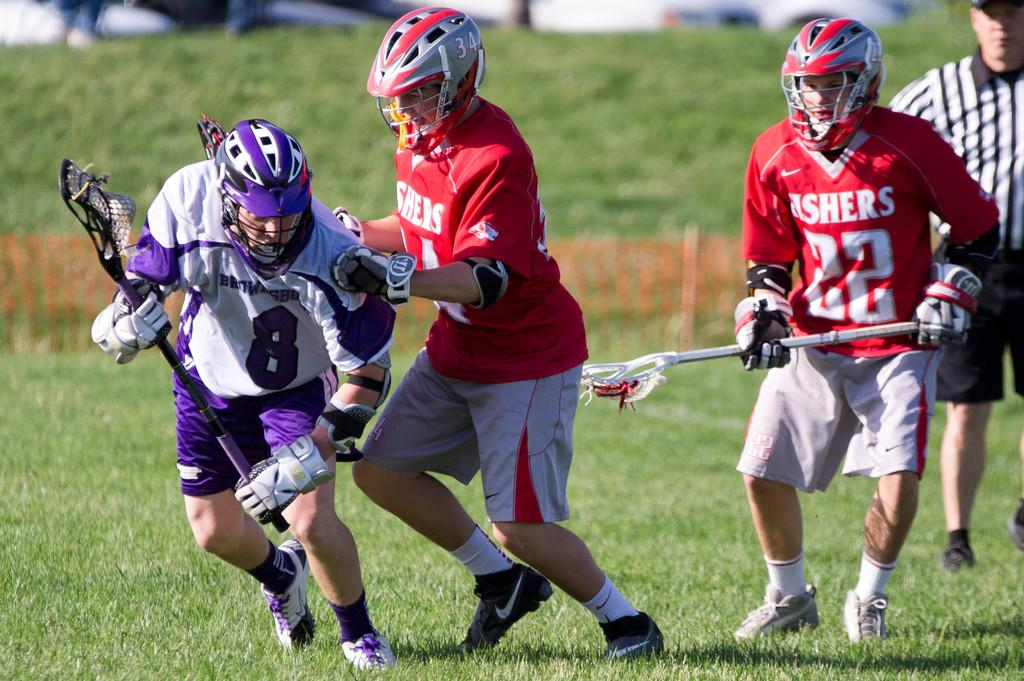How many people are present in the image? There are four people in the image. What are the people doing in the image? The people are running on the grass. What can be seen in the background of the image? There is a fence visible in the image. What type of shoe is being tied in a knot by one of the people in the image? There is: There is no shoe or knot-tying activity present in the image. 